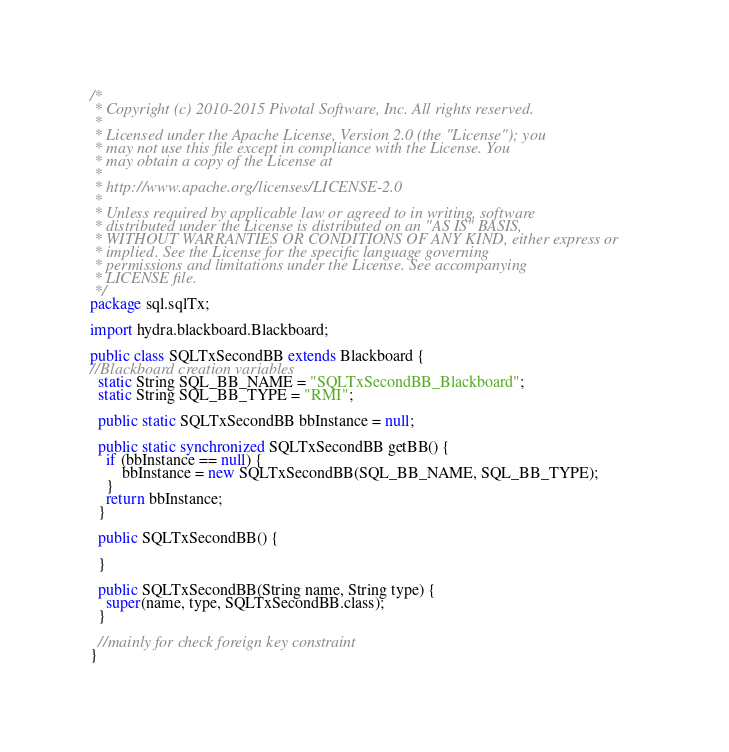Convert code to text. <code><loc_0><loc_0><loc_500><loc_500><_Java_>/*
 * Copyright (c) 2010-2015 Pivotal Software, Inc. All rights reserved.
 *
 * Licensed under the Apache License, Version 2.0 (the "License"); you
 * may not use this file except in compliance with the License. You
 * may obtain a copy of the License at
 *
 * http://www.apache.org/licenses/LICENSE-2.0
 *
 * Unless required by applicable law or agreed to in writing, software
 * distributed under the License is distributed on an "AS IS" BASIS,
 * WITHOUT WARRANTIES OR CONDITIONS OF ANY KIND, either express or
 * implied. See the License for the specific language governing
 * permissions and limitations under the License. See accompanying
 * LICENSE file.
 */
package sql.sqlTx;

import hydra.blackboard.Blackboard;

public class SQLTxSecondBB extends Blackboard {
//Blackboard creation variables
  static String SQL_BB_NAME = "SQLTxSecondBB_Blackboard";
  static String SQL_BB_TYPE = "RMI";
  
  public static SQLTxSecondBB bbInstance = null;
  
  public static synchronized SQLTxSecondBB getBB() {
    if (bbInstance == null) {
        bbInstance = new SQLTxSecondBB(SQL_BB_NAME, SQL_BB_TYPE);
    }      
    return bbInstance;  
  }
  
  public SQLTxSecondBB() {
    
  }
  
  public SQLTxSecondBB(String name, String type) {
    super(name, type, SQLTxSecondBB.class);
  }
  
  //mainly for check foreign key constraint
}
</code> 